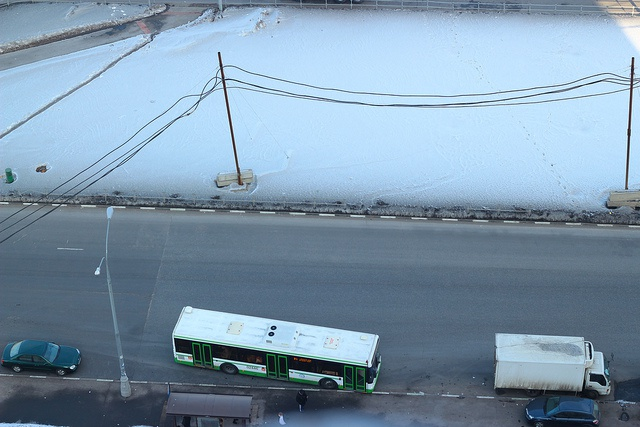Describe the objects in this image and their specific colors. I can see bus in gray, lightblue, black, and darkgreen tones, truck in gray, lightblue, darkgray, and black tones, car in gray, blue, black, darkblue, and teal tones, car in gray, black, blue, and darkblue tones, and people in gray, black, navy, and blue tones in this image. 